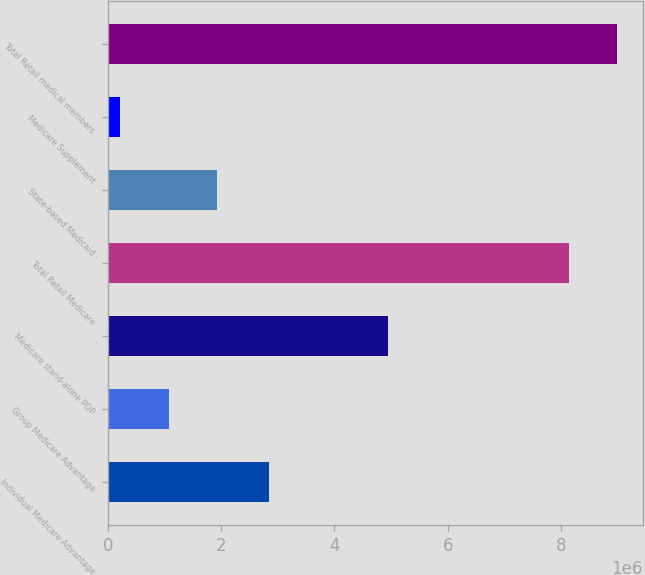<chart> <loc_0><loc_0><loc_500><loc_500><bar_chart><fcel>Individual Medicare Advantage<fcel>Group Medicare Advantage<fcel>Medicare stand-alone PDP<fcel>Total Retail Medicare<fcel>State-based Medicaid<fcel>Medicare Supplement<fcel>Total Retail medical members<nl><fcel>2.8376e+06<fcel>1.07205e+06<fcel>4.9514e+06<fcel>8.1444e+06<fcel>1.9253e+06<fcel>218800<fcel>8.99765e+06<nl></chart> 